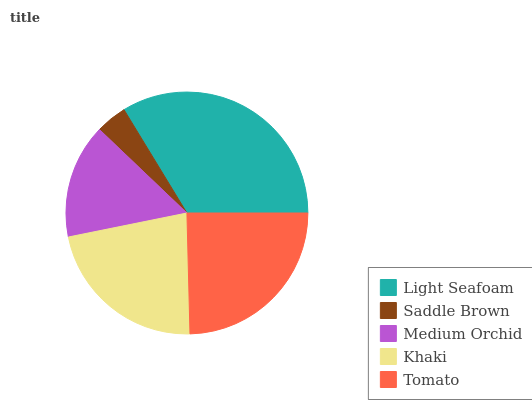Is Saddle Brown the minimum?
Answer yes or no. Yes. Is Light Seafoam the maximum?
Answer yes or no. Yes. Is Medium Orchid the minimum?
Answer yes or no. No. Is Medium Orchid the maximum?
Answer yes or no. No. Is Medium Orchid greater than Saddle Brown?
Answer yes or no. Yes. Is Saddle Brown less than Medium Orchid?
Answer yes or no. Yes. Is Saddle Brown greater than Medium Orchid?
Answer yes or no. No. Is Medium Orchid less than Saddle Brown?
Answer yes or no. No. Is Khaki the high median?
Answer yes or no. Yes. Is Khaki the low median?
Answer yes or no. Yes. Is Tomato the high median?
Answer yes or no. No. Is Saddle Brown the low median?
Answer yes or no. No. 